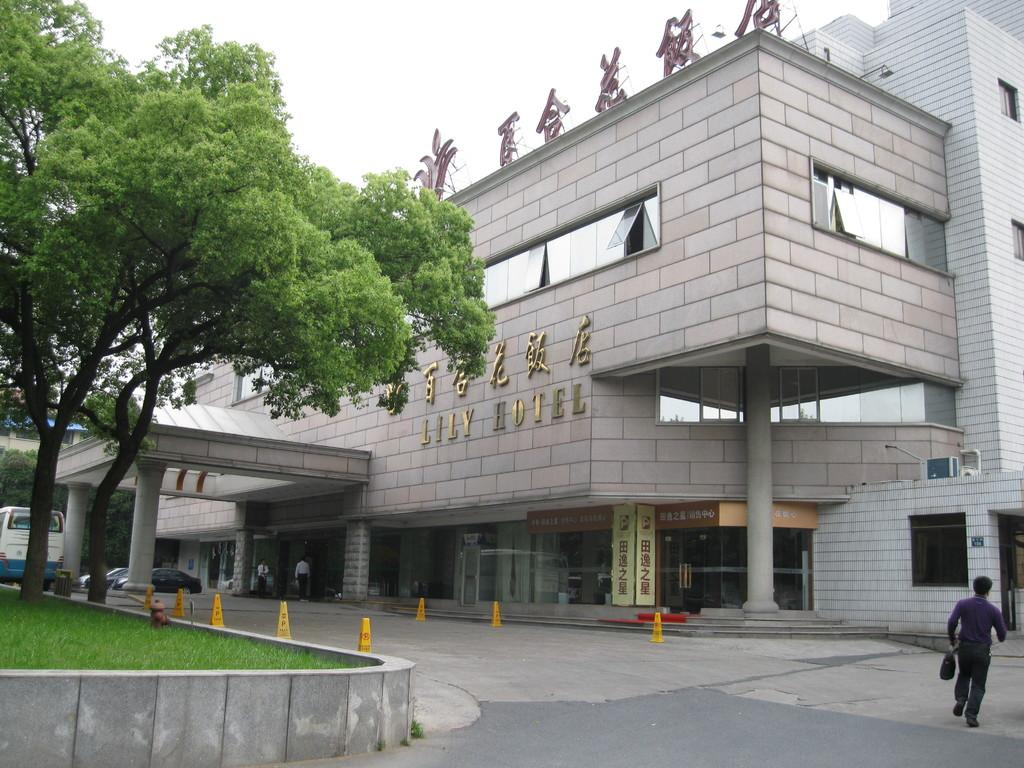What type of structure is visible in the image? There is a building in the image. What is located in front of the building? Vehicles are parked in front of the building. What safety feature is present in the image? There are divider cones in the image. What type of plant is visible in the image? There is a tree in the image. What is the person in the image doing? A person is walking on the road in the image. What type of oil can be seen draining from the tree in the image? There is no oil draining from the tree in the image; it is a regular tree. 